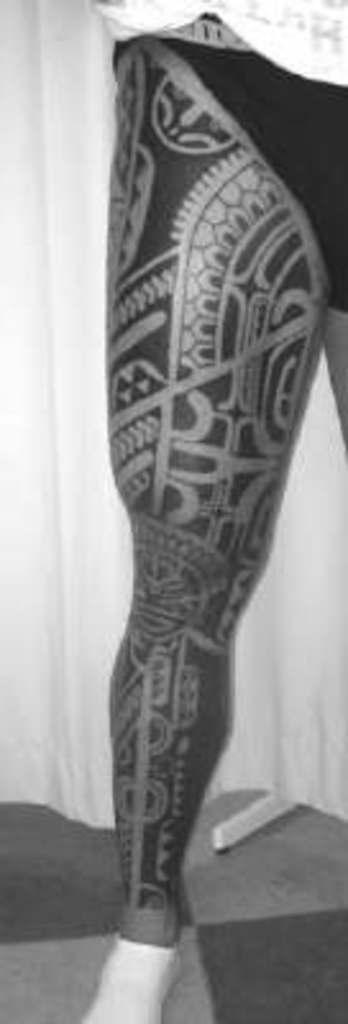Could you give a brief overview of what you see in this image? In this image we can able to see a person's leg with a tattoo on it, behind it there is a cloth. 